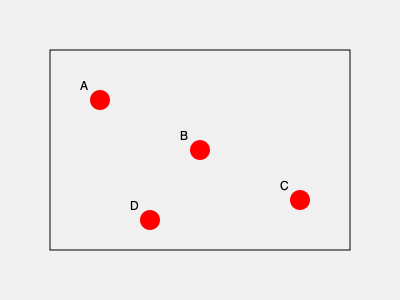Based on the map showing the distribution of women's soccer teams, which region appears to have the highest concentration of teams? To determine the region with the highest concentration of women's soccer teams, we need to analyze the distribution of the red dots on the map:

1. The map shows four teams, represented by red dots labeled A, B, C, and D.
2. We can divide the map into four quadrants: top-left, top-right, bottom-left, and bottom-right.
3. Counting the teams in each quadrant:
   - Top-left: 1 team (A)
   - Top-right: 1 team (B)
   - Bottom-left: 1 team (D)
   - Bottom-right: 1 team (C)
4. However, we notice that teams B and C are closer to the center of the map.
5. The area encompassing teams B and C has the highest density of teams within a smaller geographic area.
6. This central region, which includes parts of both the right quadrants, has the highest concentration of teams.

Therefore, the central-right area of the map shows the highest concentration of women's soccer teams.
Answer: Central-right region 